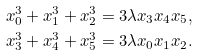<formula> <loc_0><loc_0><loc_500><loc_500>x _ { 0 } ^ { 3 } + x _ { 1 } ^ { 3 } + x _ { 2 } ^ { 3 } & = 3 \lambda x _ { 3 } x _ { 4 } x _ { 5 } , \\ x _ { 3 } ^ { 3 } + x _ { 4 } ^ { 3 } + x _ { 5 } ^ { 3 } & = 3 \lambda x _ { 0 } x _ { 1 } x _ { 2 } .</formula> 